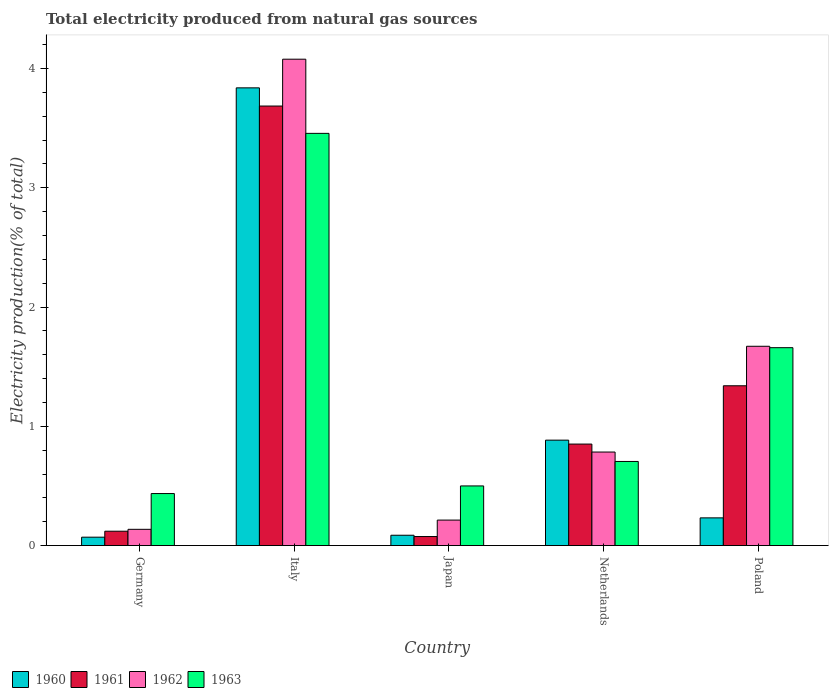How many different coloured bars are there?
Provide a succinct answer. 4. How many bars are there on the 1st tick from the right?
Your answer should be compact. 4. What is the label of the 1st group of bars from the left?
Your answer should be compact. Germany. What is the total electricity produced in 1963 in Japan?
Provide a succinct answer. 0.5. Across all countries, what is the maximum total electricity produced in 1962?
Give a very brief answer. 4.08. Across all countries, what is the minimum total electricity produced in 1960?
Provide a short and direct response. 0.07. In which country was the total electricity produced in 1961 maximum?
Give a very brief answer. Italy. In which country was the total electricity produced in 1960 minimum?
Ensure brevity in your answer.  Germany. What is the total total electricity produced in 1960 in the graph?
Make the answer very short. 5.11. What is the difference between the total electricity produced in 1960 in Japan and that in Poland?
Keep it short and to the point. -0.15. What is the difference between the total electricity produced in 1961 in Italy and the total electricity produced in 1962 in Germany?
Make the answer very short. 3.55. What is the average total electricity produced in 1960 per country?
Your answer should be very brief. 1.02. What is the difference between the total electricity produced of/in 1963 and total electricity produced of/in 1960 in Netherlands?
Make the answer very short. -0.18. What is the ratio of the total electricity produced in 1960 in Japan to that in Poland?
Offer a very short reply. 0.37. Is the difference between the total electricity produced in 1963 in Germany and Netherlands greater than the difference between the total electricity produced in 1960 in Germany and Netherlands?
Make the answer very short. Yes. What is the difference between the highest and the second highest total electricity produced in 1963?
Give a very brief answer. -0.95. What is the difference between the highest and the lowest total electricity produced in 1963?
Provide a short and direct response. 3.02. What does the 4th bar from the left in Germany represents?
Provide a short and direct response. 1963. Does the graph contain any zero values?
Offer a terse response. No. Where does the legend appear in the graph?
Your answer should be compact. Bottom left. What is the title of the graph?
Offer a very short reply. Total electricity produced from natural gas sources. Does "2011" appear as one of the legend labels in the graph?
Give a very brief answer. No. What is the Electricity production(% of total) in 1960 in Germany?
Your answer should be compact. 0.07. What is the Electricity production(% of total) in 1961 in Germany?
Your answer should be very brief. 0.12. What is the Electricity production(% of total) in 1962 in Germany?
Ensure brevity in your answer.  0.14. What is the Electricity production(% of total) in 1963 in Germany?
Keep it short and to the point. 0.44. What is the Electricity production(% of total) of 1960 in Italy?
Provide a short and direct response. 3.84. What is the Electricity production(% of total) of 1961 in Italy?
Your response must be concise. 3.69. What is the Electricity production(% of total) of 1962 in Italy?
Give a very brief answer. 4.08. What is the Electricity production(% of total) in 1963 in Italy?
Your answer should be compact. 3.46. What is the Electricity production(% of total) in 1960 in Japan?
Keep it short and to the point. 0.09. What is the Electricity production(% of total) of 1961 in Japan?
Give a very brief answer. 0.08. What is the Electricity production(% of total) in 1962 in Japan?
Your response must be concise. 0.21. What is the Electricity production(% of total) of 1963 in Japan?
Your answer should be very brief. 0.5. What is the Electricity production(% of total) of 1960 in Netherlands?
Offer a very short reply. 0.88. What is the Electricity production(% of total) of 1961 in Netherlands?
Keep it short and to the point. 0.85. What is the Electricity production(% of total) in 1962 in Netherlands?
Provide a short and direct response. 0.78. What is the Electricity production(% of total) in 1963 in Netherlands?
Ensure brevity in your answer.  0.71. What is the Electricity production(% of total) in 1960 in Poland?
Make the answer very short. 0.23. What is the Electricity production(% of total) in 1961 in Poland?
Provide a succinct answer. 1.34. What is the Electricity production(% of total) of 1962 in Poland?
Keep it short and to the point. 1.67. What is the Electricity production(% of total) of 1963 in Poland?
Keep it short and to the point. 1.66. Across all countries, what is the maximum Electricity production(% of total) in 1960?
Provide a succinct answer. 3.84. Across all countries, what is the maximum Electricity production(% of total) in 1961?
Ensure brevity in your answer.  3.69. Across all countries, what is the maximum Electricity production(% of total) of 1962?
Keep it short and to the point. 4.08. Across all countries, what is the maximum Electricity production(% of total) in 1963?
Give a very brief answer. 3.46. Across all countries, what is the minimum Electricity production(% of total) of 1960?
Your answer should be very brief. 0.07. Across all countries, what is the minimum Electricity production(% of total) of 1961?
Provide a succinct answer. 0.08. Across all countries, what is the minimum Electricity production(% of total) of 1962?
Give a very brief answer. 0.14. Across all countries, what is the minimum Electricity production(% of total) in 1963?
Give a very brief answer. 0.44. What is the total Electricity production(% of total) of 1960 in the graph?
Make the answer very short. 5.11. What is the total Electricity production(% of total) in 1961 in the graph?
Make the answer very short. 6.07. What is the total Electricity production(% of total) of 1962 in the graph?
Your answer should be very brief. 6.88. What is the total Electricity production(% of total) in 1963 in the graph?
Offer a very short reply. 6.76. What is the difference between the Electricity production(% of total) of 1960 in Germany and that in Italy?
Your answer should be compact. -3.77. What is the difference between the Electricity production(% of total) of 1961 in Germany and that in Italy?
Your response must be concise. -3.57. What is the difference between the Electricity production(% of total) of 1962 in Germany and that in Italy?
Offer a very short reply. -3.94. What is the difference between the Electricity production(% of total) of 1963 in Germany and that in Italy?
Your response must be concise. -3.02. What is the difference between the Electricity production(% of total) in 1960 in Germany and that in Japan?
Give a very brief answer. -0.02. What is the difference between the Electricity production(% of total) in 1961 in Germany and that in Japan?
Your response must be concise. 0.04. What is the difference between the Electricity production(% of total) of 1962 in Germany and that in Japan?
Ensure brevity in your answer.  -0.08. What is the difference between the Electricity production(% of total) of 1963 in Germany and that in Japan?
Your answer should be compact. -0.06. What is the difference between the Electricity production(% of total) of 1960 in Germany and that in Netherlands?
Offer a very short reply. -0.81. What is the difference between the Electricity production(% of total) in 1961 in Germany and that in Netherlands?
Your response must be concise. -0.73. What is the difference between the Electricity production(% of total) of 1962 in Germany and that in Netherlands?
Offer a very short reply. -0.65. What is the difference between the Electricity production(% of total) in 1963 in Germany and that in Netherlands?
Keep it short and to the point. -0.27. What is the difference between the Electricity production(% of total) of 1960 in Germany and that in Poland?
Ensure brevity in your answer.  -0.16. What is the difference between the Electricity production(% of total) in 1961 in Germany and that in Poland?
Ensure brevity in your answer.  -1.22. What is the difference between the Electricity production(% of total) in 1962 in Germany and that in Poland?
Keep it short and to the point. -1.53. What is the difference between the Electricity production(% of total) of 1963 in Germany and that in Poland?
Ensure brevity in your answer.  -1.22. What is the difference between the Electricity production(% of total) in 1960 in Italy and that in Japan?
Keep it short and to the point. 3.75. What is the difference between the Electricity production(% of total) in 1961 in Italy and that in Japan?
Offer a very short reply. 3.61. What is the difference between the Electricity production(% of total) of 1962 in Italy and that in Japan?
Your answer should be compact. 3.86. What is the difference between the Electricity production(% of total) of 1963 in Italy and that in Japan?
Your response must be concise. 2.96. What is the difference between the Electricity production(% of total) of 1960 in Italy and that in Netherlands?
Offer a very short reply. 2.95. What is the difference between the Electricity production(% of total) in 1961 in Italy and that in Netherlands?
Ensure brevity in your answer.  2.83. What is the difference between the Electricity production(% of total) of 1962 in Italy and that in Netherlands?
Your answer should be compact. 3.29. What is the difference between the Electricity production(% of total) in 1963 in Italy and that in Netherlands?
Give a very brief answer. 2.75. What is the difference between the Electricity production(% of total) of 1960 in Italy and that in Poland?
Your answer should be very brief. 3.61. What is the difference between the Electricity production(% of total) of 1961 in Italy and that in Poland?
Ensure brevity in your answer.  2.35. What is the difference between the Electricity production(% of total) in 1962 in Italy and that in Poland?
Your answer should be very brief. 2.41. What is the difference between the Electricity production(% of total) of 1963 in Italy and that in Poland?
Provide a short and direct response. 1.8. What is the difference between the Electricity production(% of total) in 1960 in Japan and that in Netherlands?
Provide a short and direct response. -0.8. What is the difference between the Electricity production(% of total) in 1961 in Japan and that in Netherlands?
Your response must be concise. -0.78. What is the difference between the Electricity production(% of total) of 1962 in Japan and that in Netherlands?
Make the answer very short. -0.57. What is the difference between the Electricity production(% of total) of 1963 in Japan and that in Netherlands?
Your answer should be very brief. -0.21. What is the difference between the Electricity production(% of total) of 1960 in Japan and that in Poland?
Your response must be concise. -0.15. What is the difference between the Electricity production(% of total) of 1961 in Japan and that in Poland?
Offer a terse response. -1.26. What is the difference between the Electricity production(% of total) in 1962 in Japan and that in Poland?
Make the answer very short. -1.46. What is the difference between the Electricity production(% of total) in 1963 in Japan and that in Poland?
Provide a short and direct response. -1.16. What is the difference between the Electricity production(% of total) in 1960 in Netherlands and that in Poland?
Ensure brevity in your answer.  0.65. What is the difference between the Electricity production(% of total) of 1961 in Netherlands and that in Poland?
Keep it short and to the point. -0.49. What is the difference between the Electricity production(% of total) of 1962 in Netherlands and that in Poland?
Keep it short and to the point. -0.89. What is the difference between the Electricity production(% of total) of 1963 in Netherlands and that in Poland?
Keep it short and to the point. -0.95. What is the difference between the Electricity production(% of total) of 1960 in Germany and the Electricity production(% of total) of 1961 in Italy?
Your answer should be very brief. -3.62. What is the difference between the Electricity production(% of total) in 1960 in Germany and the Electricity production(% of total) in 1962 in Italy?
Offer a very short reply. -4.01. What is the difference between the Electricity production(% of total) of 1960 in Germany and the Electricity production(% of total) of 1963 in Italy?
Provide a short and direct response. -3.39. What is the difference between the Electricity production(% of total) of 1961 in Germany and the Electricity production(% of total) of 1962 in Italy?
Keep it short and to the point. -3.96. What is the difference between the Electricity production(% of total) in 1961 in Germany and the Electricity production(% of total) in 1963 in Italy?
Give a very brief answer. -3.34. What is the difference between the Electricity production(% of total) of 1962 in Germany and the Electricity production(% of total) of 1963 in Italy?
Keep it short and to the point. -3.32. What is the difference between the Electricity production(% of total) of 1960 in Germany and the Electricity production(% of total) of 1961 in Japan?
Your response must be concise. -0.01. What is the difference between the Electricity production(% of total) of 1960 in Germany and the Electricity production(% of total) of 1962 in Japan?
Keep it short and to the point. -0.14. What is the difference between the Electricity production(% of total) of 1960 in Germany and the Electricity production(% of total) of 1963 in Japan?
Keep it short and to the point. -0.43. What is the difference between the Electricity production(% of total) in 1961 in Germany and the Electricity production(% of total) in 1962 in Japan?
Your answer should be very brief. -0.09. What is the difference between the Electricity production(% of total) in 1961 in Germany and the Electricity production(% of total) in 1963 in Japan?
Offer a terse response. -0.38. What is the difference between the Electricity production(% of total) of 1962 in Germany and the Electricity production(% of total) of 1963 in Japan?
Keep it short and to the point. -0.36. What is the difference between the Electricity production(% of total) in 1960 in Germany and the Electricity production(% of total) in 1961 in Netherlands?
Make the answer very short. -0.78. What is the difference between the Electricity production(% of total) in 1960 in Germany and the Electricity production(% of total) in 1962 in Netherlands?
Offer a very short reply. -0.71. What is the difference between the Electricity production(% of total) of 1960 in Germany and the Electricity production(% of total) of 1963 in Netherlands?
Give a very brief answer. -0.64. What is the difference between the Electricity production(% of total) in 1961 in Germany and the Electricity production(% of total) in 1962 in Netherlands?
Ensure brevity in your answer.  -0.66. What is the difference between the Electricity production(% of total) in 1961 in Germany and the Electricity production(% of total) in 1963 in Netherlands?
Your answer should be compact. -0.58. What is the difference between the Electricity production(% of total) of 1962 in Germany and the Electricity production(% of total) of 1963 in Netherlands?
Your response must be concise. -0.57. What is the difference between the Electricity production(% of total) in 1960 in Germany and the Electricity production(% of total) in 1961 in Poland?
Your response must be concise. -1.27. What is the difference between the Electricity production(% of total) in 1960 in Germany and the Electricity production(% of total) in 1962 in Poland?
Give a very brief answer. -1.6. What is the difference between the Electricity production(% of total) in 1960 in Germany and the Electricity production(% of total) in 1963 in Poland?
Make the answer very short. -1.59. What is the difference between the Electricity production(% of total) of 1961 in Germany and the Electricity production(% of total) of 1962 in Poland?
Offer a very short reply. -1.55. What is the difference between the Electricity production(% of total) of 1961 in Germany and the Electricity production(% of total) of 1963 in Poland?
Provide a succinct answer. -1.54. What is the difference between the Electricity production(% of total) in 1962 in Germany and the Electricity production(% of total) in 1963 in Poland?
Provide a succinct answer. -1.52. What is the difference between the Electricity production(% of total) in 1960 in Italy and the Electricity production(% of total) in 1961 in Japan?
Provide a succinct answer. 3.76. What is the difference between the Electricity production(% of total) in 1960 in Italy and the Electricity production(% of total) in 1962 in Japan?
Ensure brevity in your answer.  3.62. What is the difference between the Electricity production(% of total) of 1960 in Italy and the Electricity production(% of total) of 1963 in Japan?
Offer a very short reply. 3.34. What is the difference between the Electricity production(% of total) of 1961 in Italy and the Electricity production(% of total) of 1962 in Japan?
Make the answer very short. 3.47. What is the difference between the Electricity production(% of total) of 1961 in Italy and the Electricity production(% of total) of 1963 in Japan?
Give a very brief answer. 3.19. What is the difference between the Electricity production(% of total) of 1962 in Italy and the Electricity production(% of total) of 1963 in Japan?
Your answer should be compact. 3.58. What is the difference between the Electricity production(% of total) of 1960 in Italy and the Electricity production(% of total) of 1961 in Netherlands?
Your answer should be very brief. 2.99. What is the difference between the Electricity production(% of total) of 1960 in Italy and the Electricity production(% of total) of 1962 in Netherlands?
Ensure brevity in your answer.  3.05. What is the difference between the Electricity production(% of total) of 1960 in Italy and the Electricity production(% of total) of 1963 in Netherlands?
Your answer should be compact. 3.13. What is the difference between the Electricity production(% of total) of 1961 in Italy and the Electricity production(% of total) of 1962 in Netherlands?
Offer a very short reply. 2.9. What is the difference between the Electricity production(% of total) in 1961 in Italy and the Electricity production(% of total) in 1963 in Netherlands?
Give a very brief answer. 2.98. What is the difference between the Electricity production(% of total) in 1962 in Italy and the Electricity production(% of total) in 1963 in Netherlands?
Your response must be concise. 3.37. What is the difference between the Electricity production(% of total) in 1960 in Italy and the Electricity production(% of total) in 1961 in Poland?
Give a very brief answer. 2.5. What is the difference between the Electricity production(% of total) in 1960 in Italy and the Electricity production(% of total) in 1962 in Poland?
Ensure brevity in your answer.  2.17. What is the difference between the Electricity production(% of total) of 1960 in Italy and the Electricity production(% of total) of 1963 in Poland?
Offer a very short reply. 2.18. What is the difference between the Electricity production(% of total) in 1961 in Italy and the Electricity production(% of total) in 1962 in Poland?
Ensure brevity in your answer.  2.01. What is the difference between the Electricity production(% of total) of 1961 in Italy and the Electricity production(% of total) of 1963 in Poland?
Ensure brevity in your answer.  2.03. What is the difference between the Electricity production(% of total) in 1962 in Italy and the Electricity production(% of total) in 1963 in Poland?
Provide a short and direct response. 2.42. What is the difference between the Electricity production(% of total) of 1960 in Japan and the Electricity production(% of total) of 1961 in Netherlands?
Ensure brevity in your answer.  -0.76. What is the difference between the Electricity production(% of total) of 1960 in Japan and the Electricity production(% of total) of 1962 in Netherlands?
Provide a short and direct response. -0.7. What is the difference between the Electricity production(% of total) in 1960 in Japan and the Electricity production(% of total) in 1963 in Netherlands?
Offer a terse response. -0.62. What is the difference between the Electricity production(% of total) of 1961 in Japan and the Electricity production(% of total) of 1962 in Netherlands?
Provide a short and direct response. -0.71. What is the difference between the Electricity production(% of total) in 1961 in Japan and the Electricity production(% of total) in 1963 in Netherlands?
Ensure brevity in your answer.  -0.63. What is the difference between the Electricity production(% of total) of 1962 in Japan and the Electricity production(% of total) of 1963 in Netherlands?
Offer a very short reply. -0.49. What is the difference between the Electricity production(% of total) of 1960 in Japan and the Electricity production(% of total) of 1961 in Poland?
Offer a very short reply. -1.25. What is the difference between the Electricity production(% of total) of 1960 in Japan and the Electricity production(% of total) of 1962 in Poland?
Your answer should be compact. -1.58. What is the difference between the Electricity production(% of total) of 1960 in Japan and the Electricity production(% of total) of 1963 in Poland?
Provide a short and direct response. -1.57. What is the difference between the Electricity production(% of total) in 1961 in Japan and the Electricity production(% of total) in 1962 in Poland?
Offer a terse response. -1.6. What is the difference between the Electricity production(% of total) of 1961 in Japan and the Electricity production(% of total) of 1963 in Poland?
Give a very brief answer. -1.58. What is the difference between the Electricity production(% of total) in 1962 in Japan and the Electricity production(% of total) in 1963 in Poland?
Keep it short and to the point. -1.45. What is the difference between the Electricity production(% of total) of 1960 in Netherlands and the Electricity production(% of total) of 1961 in Poland?
Make the answer very short. -0.46. What is the difference between the Electricity production(% of total) in 1960 in Netherlands and the Electricity production(% of total) in 1962 in Poland?
Ensure brevity in your answer.  -0.79. What is the difference between the Electricity production(% of total) of 1960 in Netherlands and the Electricity production(% of total) of 1963 in Poland?
Offer a terse response. -0.78. What is the difference between the Electricity production(% of total) of 1961 in Netherlands and the Electricity production(% of total) of 1962 in Poland?
Your answer should be very brief. -0.82. What is the difference between the Electricity production(% of total) in 1961 in Netherlands and the Electricity production(% of total) in 1963 in Poland?
Keep it short and to the point. -0.81. What is the difference between the Electricity production(% of total) of 1962 in Netherlands and the Electricity production(% of total) of 1963 in Poland?
Your answer should be very brief. -0.88. What is the average Electricity production(% of total) of 1960 per country?
Make the answer very short. 1.02. What is the average Electricity production(% of total) in 1961 per country?
Your answer should be very brief. 1.21. What is the average Electricity production(% of total) in 1962 per country?
Keep it short and to the point. 1.38. What is the average Electricity production(% of total) of 1963 per country?
Your answer should be compact. 1.35. What is the difference between the Electricity production(% of total) of 1960 and Electricity production(% of total) of 1962 in Germany?
Give a very brief answer. -0.07. What is the difference between the Electricity production(% of total) in 1960 and Electricity production(% of total) in 1963 in Germany?
Make the answer very short. -0.37. What is the difference between the Electricity production(% of total) of 1961 and Electricity production(% of total) of 1962 in Germany?
Your answer should be compact. -0.02. What is the difference between the Electricity production(% of total) of 1961 and Electricity production(% of total) of 1963 in Germany?
Provide a succinct answer. -0.32. What is the difference between the Electricity production(% of total) of 1962 and Electricity production(% of total) of 1963 in Germany?
Your response must be concise. -0.3. What is the difference between the Electricity production(% of total) in 1960 and Electricity production(% of total) in 1961 in Italy?
Your answer should be very brief. 0.15. What is the difference between the Electricity production(% of total) in 1960 and Electricity production(% of total) in 1962 in Italy?
Your response must be concise. -0.24. What is the difference between the Electricity production(% of total) of 1960 and Electricity production(% of total) of 1963 in Italy?
Offer a terse response. 0.38. What is the difference between the Electricity production(% of total) of 1961 and Electricity production(% of total) of 1962 in Italy?
Offer a terse response. -0.39. What is the difference between the Electricity production(% of total) of 1961 and Electricity production(% of total) of 1963 in Italy?
Provide a short and direct response. 0.23. What is the difference between the Electricity production(% of total) in 1962 and Electricity production(% of total) in 1963 in Italy?
Keep it short and to the point. 0.62. What is the difference between the Electricity production(% of total) in 1960 and Electricity production(% of total) in 1961 in Japan?
Your response must be concise. 0.01. What is the difference between the Electricity production(% of total) of 1960 and Electricity production(% of total) of 1962 in Japan?
Ensure brevity in your answer.  -0.13. What is the difference between the Electricity production(% of total) in 1960 and Electricity production(% of total) in 1963 in Japan?
Offer a very short reply. -0.41. What is the difference between the Electricity production(% of total) of 1961 and Electricity production(% of total) of 1962 in Japan?
Offer a terse response. -0.14. What is the difference between the Electricity production(% of total) in 1961 and Electricity production(% of total) in 1963 in Japan?
Your answer should be compact. -0.42. What is the difference between the Electricity production(% of total) in 1962 and Electricity production(% of total) in 1963 in Japan?
Offer a terse response. -0.29. What is the difference between the Electricity production(% of total) in 1960 and Electricity production(% of total) in 1961 in Netherlands?
Your response must be concise. 0.03. What is the difference between the Electricity production(% of total) in 1960 and Electricity production(% of total) in 1962 in Netherlands?
Offer a terse response. 0.1. What is the difference between the Electricity production(% of total) in 1960 and Electricity production(% of total) in 1963 in Netherlands?
Provide a short and direct response. 0.18. What is the difference between the Electricity production(% of total) in 1961 and Electricity production(% of total) in 1962 in Netherlands?
Ensure brevity in your answer.  0.07. What is the difference between the Electricity production(% of total) in 1961 and Electricity production(% of total) in 1963 in Netherlands?
Give a very brief answer. 0.15. What is the difference between the Electricity production(% of total) in 1962 and Electricity production(% of total) in 1963 in Netherlands?
Ensure brevity in your answer.  0.08. What is the difference between the Electricity production(% of total) in 1960 and Electricity production(% of total) in 1961 in Poland?
Offer a very short reply. -1.11. What is the difference between the Electricity production(% of total) of 1960 and Electricity production(% of total) of 1962 in Poland?
Ensure brevity in your answer.  -1.44. What is the difference between the Electricity production(% of total) in 1960 and Electricity production(% of total) in 1963 in Poland?
Give a very brief answer. -1.43. What is the difference between the Electricity production(% of total) of 1961 and Electricity production(% of total) of 1962 in Poland?
Make the answer very short. -0.33. What is the difference between the Electricity production(% of total) of 1961 and Electricity production(% of total) of 1963 in Poland?
Offer a very short reply. -0.32. What is the difference between the Electricity production(% of total) of 1962 and Electricity production(% of total) of 1963 in Poland?
Make the answer very short. 0.01. What is the ratio of the Electricity production(% of total) in 1960 in Germany to that in Italy?
Provide a succinct answer. 0.02. What is the ratio of the Electricity production(% of total) of 1961 in Germany to that in Italy?
Your response must be concise. 0.03. What is the ratio of the Electricity production(% of total) in 1962 in Germany to that in Italy?
Your response must be concise. 0.03. What is the ratio of the Electricity production(% of total) in 1963 in Germany to that in Italy?
Your answer should be very brief. 0.13. What is the ratio of the Electricity production(% of total) in 1960 in Germany to that in Japan?
Provide a succinct answer. 0.81. What is the ratio of the Electricity production(% of total) of 1961 in Germany to that in Japan?
Offer a very short reply. 1.59. What is the ratio of the Electricity production(% of total) of 1962 in Germany to that in Japan?
Give a very brief answer. 0.64. What is the ratio of the Electricity production(% of total) of 1963 in Germany to that in Japan?
Make the answer very short. 0.87. What is the ratio of the Electricity production(% of total) of 1960 in Germany to that in Netherlands?
Offer a terse response. 0.08. What is the ratio of the Electricity production(% of total) in 1961 in Germany to that in Netherlands?
Provide a short and direct response. 0.14. What is the ratio of the Electricity production(% of total) of 1962 in Germany to that in Netherlands?
Ensure brevity in your answer.  0.17. What is the ratio of the Electricity production(% of total) in 1963 in Germany to that in Netherlands?
Your response must be concise. 0.62. What is the ratio of the Electricity production(% of total) in 1960 in Germany to that in Poland?
Your response must be concise. 0.3. What is the ratio of the Electricity production(% of total) of 1961 in Germany to that in Poland?
Offer a very short reply. 0.09. What is the ratio of the Electricity production(% of total) of 1962 in Germany to that in Poland?
Ensure brevity in your answer.  0.08. What is the ratio of the Electricity production(% of total) in 1963 in Germany to that in Poland?
Make the answer very short. 0.26. What is the ratio of the Electricity production(% of total) in 1960 in Italy to that in Japan?
Offer a very short reply. 44.33. What is the ratio of the Electricity production(% of total) of 1961 in Italy to that in Japan?
Make the answer very short. 48.69. What is the ratio of the Electricity production(% of total) in 1962 in Italy to that in Japan?
Provide a succinct answer. 19.09. What is the ratio of the Electricity production(% of total) of 1963 in Italy to that in Japan?
Your answer should be very brief. 6.91. What is the ratio of the Electricity production(% of total) in 1960 in Italy to that in Netherlands?
Your response must be concise. 4.34. What is the ratio of the Electricity production(% of total) in 1961 in Italy to that in Netherlands?
Keep it short and to the point. 4.33. What is the ratio of the Electricity production(% of total) in 1962 in Italy to that in Netherlands?
Provide a succinct answer. 5.2. What is the ratio of the Electricity production(% of total) of 1963 in Italy to that in Netherlands?
Your answer should be very brief. 4.9. What is the ratio of the Electricity production(% of total) in 1960 in Italy to that in Poland?
Provide a short and direct response. 16.53. What is the ratio of the Electricity production(% of total) in 1961 in Italy to that in Poland?
Your response must be concise. 2.75. What is the ratio of the Electricity production(% of total) in 1962 in Italy to that in Poland?
Offer a very short reply. 2.44. What is the ratio of the Electricity production(% of total) in 1963 in Italy to that in Poland?
Your answer should be very brief. 2.08. What is the ratio of the Electricity production(% of total) in 1960 in Japan to that in Netherlands?
Your answer should be very brief. 0.1. What is the ratio of the Electricity production(% of total) in 1961 in Japan to that in Netherlands?
Provide a short and direct response. 0.09. What is the ratio of the Electricity production(% of total) of 1962 in Japan to that in Netherlands?
Give a very brief answer. 0.27. What is the ratio of the Electricity production(% of total) in 1963 in Japan to that in Netherlands?
Your response must be concise. 0.71. What is the ratio of the Electricity production(% of total) in 1960 in Japan to that in Poland?
Provide a succinct answer. 0.37. What is the ratio of the Electricity production(% of total) of 1961 in Japan to that in Poland?
Provide a short and direct response. 0.06. What is the ratio of the Electricity production(% of total) in 1962 in Japan to that in Poland?
Make the answer very short. 0.13. What is the ratio of the Electricity production(% of total) in 1963 in Japan to that in Poland?
Keep it short and to the point. 0.3. What is the ratio of the Electricity production(% of total) of 1960 in Netherlands to that in Poland?
Your answer should be very brief. 3.81. What is the ratio of the Electricity production(% of total) in 1961 in Netherlands to that in Poland?
Give a very brief answer. 0.64. What is the ratio of the Electricity production(% of total) of 1962 in Netherlands to that in Poland?
Make the answer very short. 0.47. What is the ratio of the Electricity production(% of total) of 1963 in Netherlands to that in Poland?
Offer a terse response. 0.42. What is the difference between the highest and the second highest Electricity production(% of total) in 1960?
Provide a short and direct response. 2.95. What is the difference between the highest and the second highest Electricity production(% of total) in 1961?
Offer a very short reply. 2.35. What is the difference between the highest and the second highest Electricity production(% of total) of 1962?
Your answer should be compact. 2.41. What is the difference between the highest and the second highest Electricity production(% of total) in 1963?
Provide a short and direct response. 1.8. What is the difference between the highest and the lowest Electricity production(% of total) of 1960?
Your answer should be very brief. 3.77. What is the difference between the highest and the lowest Electricity production(% of total) of 1961?
Your answer should be very brief. 3.61. What is the difference between the highest and the lowest Electricity production(% of total) of 1962?
Your response must be concise. 3.94. What is the difference between the highest and the lowest Electricity production(% of total) of 1963?
Provide a short and direct response. 3.02. 